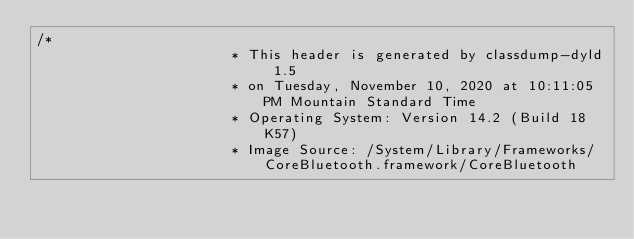<code> <loc_0><loc_0><loc_500><loc_500><_C_>/*
                       * This header is generated by classdump-dyld 1.5
                       * on Tuesday, November 10, 2020 at 10:11:05 PM Mountain Standard Time
                       * Operating System: Version 14.2 (Build 18K57)
                       * Image Source: /System/Library/Frameworks/CoreBluetooth.framework/CoreBluetooth</code> 